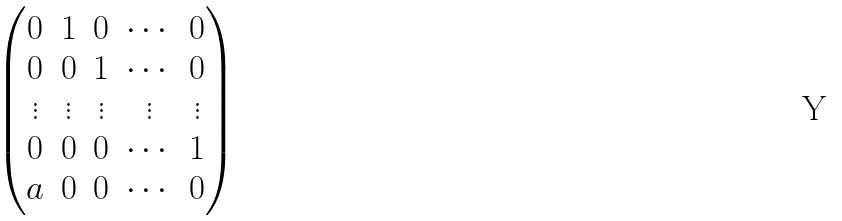<formula> <loc_0><loc_0><loc_500><loc_500>\begin{pmatrix} 0 & 1 & 0 & \cdots & 0 \\ 0 & 0 & 1 & \cdots & 0 \\ \vdots & \vdots & \vdots & \vdots & \vdots \\ 0 & 0 & 0 & \cdots & 1 \\ a & 0 & 0 & \cdots & 0 \end{pmatrix}</formula> 